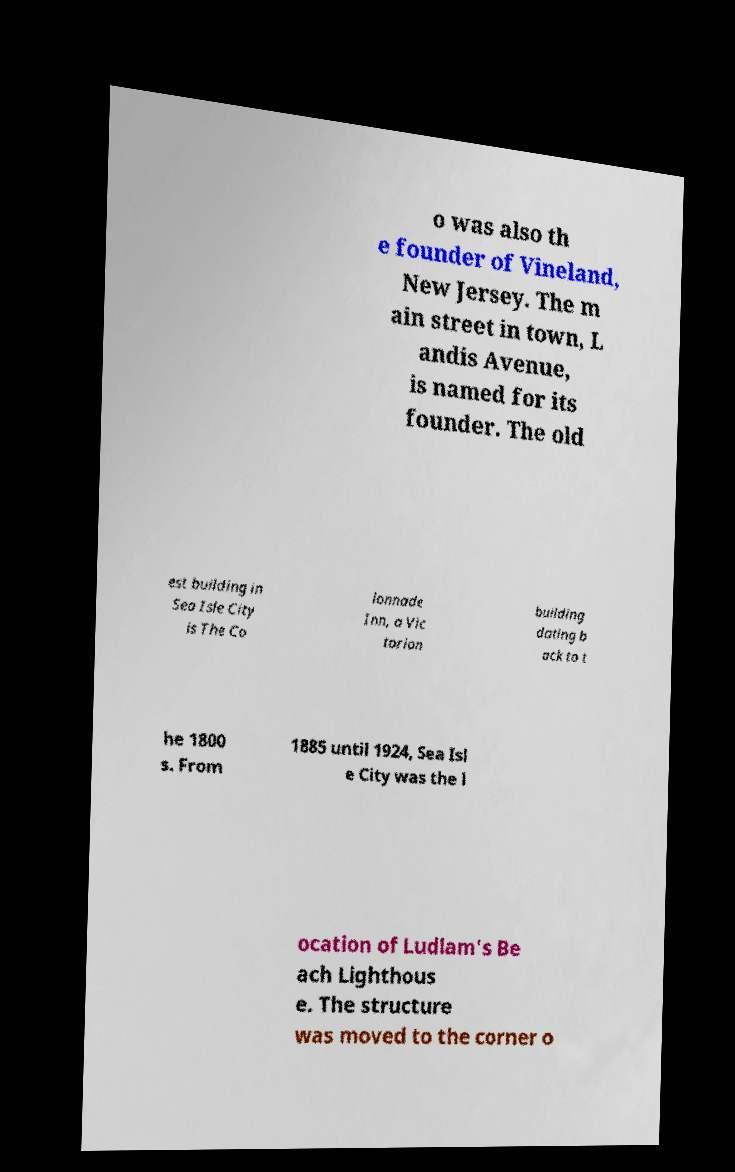Please read and relay the text visible in this image. What does it say? o was also th e founder of Vineland, New Jersey. The m ain street in town, L andis Avenue, is named for its founder. The old est building in Sea Isle City is The Co lonnade Inn, a Vic torian building dating b ack to t he 1800 s. From 1885 until 1924, Sea Isl e City was the l ocation of Ludlam's Be ach Lighthous e. The structure was moved to the corner o 